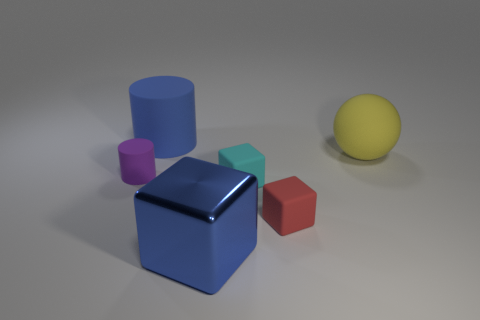Add 2 large purple rubber cylinders. How many objects exist? 8 Subtract all cylinders. How many objects are left? 4 Add 6 small red blocks. How many small red blocks exist? 7 Subtract 0 brown spheres. How many objects are left? 6 Subtract all large blue metal cubes. Subtract all purple things. How many objects are left? 4 Add 4 small purple rubber things. How many small purple rubber things are left? 5 